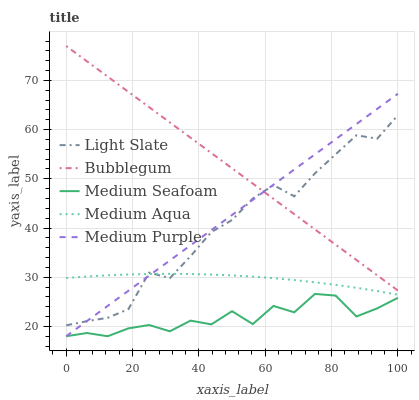Does Medium Seafoam have the minimum area under the curve?
Answer yes or no. Yes. Does Bubblegum have the maximum area under the curve?
Answer yes or no. Yes. Does Medium Purple have the minimum area under the curve?
Answer yes or no. No. Does Medium Purple have the maximum area under the curve?
Answer yes or no. No. Is Medium Purple the smoothest?
Answer yes or no. Yes. Is Medium Seafoam the roughest?
Answer yes or no. Yes. Is Medium Aqua the smoothest?
Answer yes or no. No. Is Medium Aqua the roughest?
Answer yes or no. No. Does Medium Aqua have the lowest value?
Answer yes or no. No. Does Medium Purple have the highest value?
Answer yes or no. No. Is Medium Aqua less than Bubblegum?
Answer yes or no. Yes. Is Bubblegum greater than Medium Aqua?
Answer yes or no. Yes. Does Medium Aqua intersect Bubblegum?
Answer yes or no. No. 